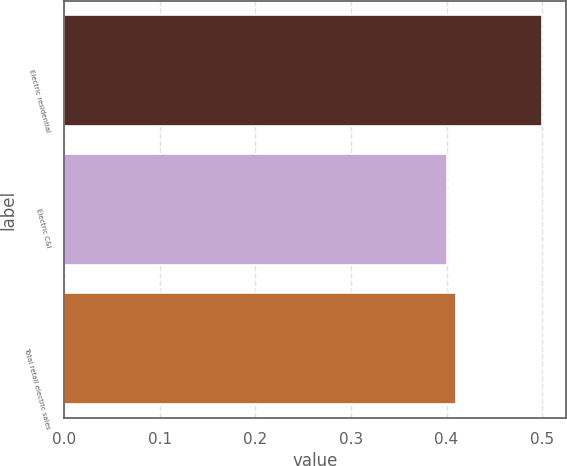Convert chart. <chart><loc_0><loc_0><loc_500><loc_500><bar_chart><fcel>Electric residential<fcel>Electric C&I<fcel>Total retail electric sales<nl><fcel>0.5<fcel>0.4<fcel>0.41<nl></chart> 